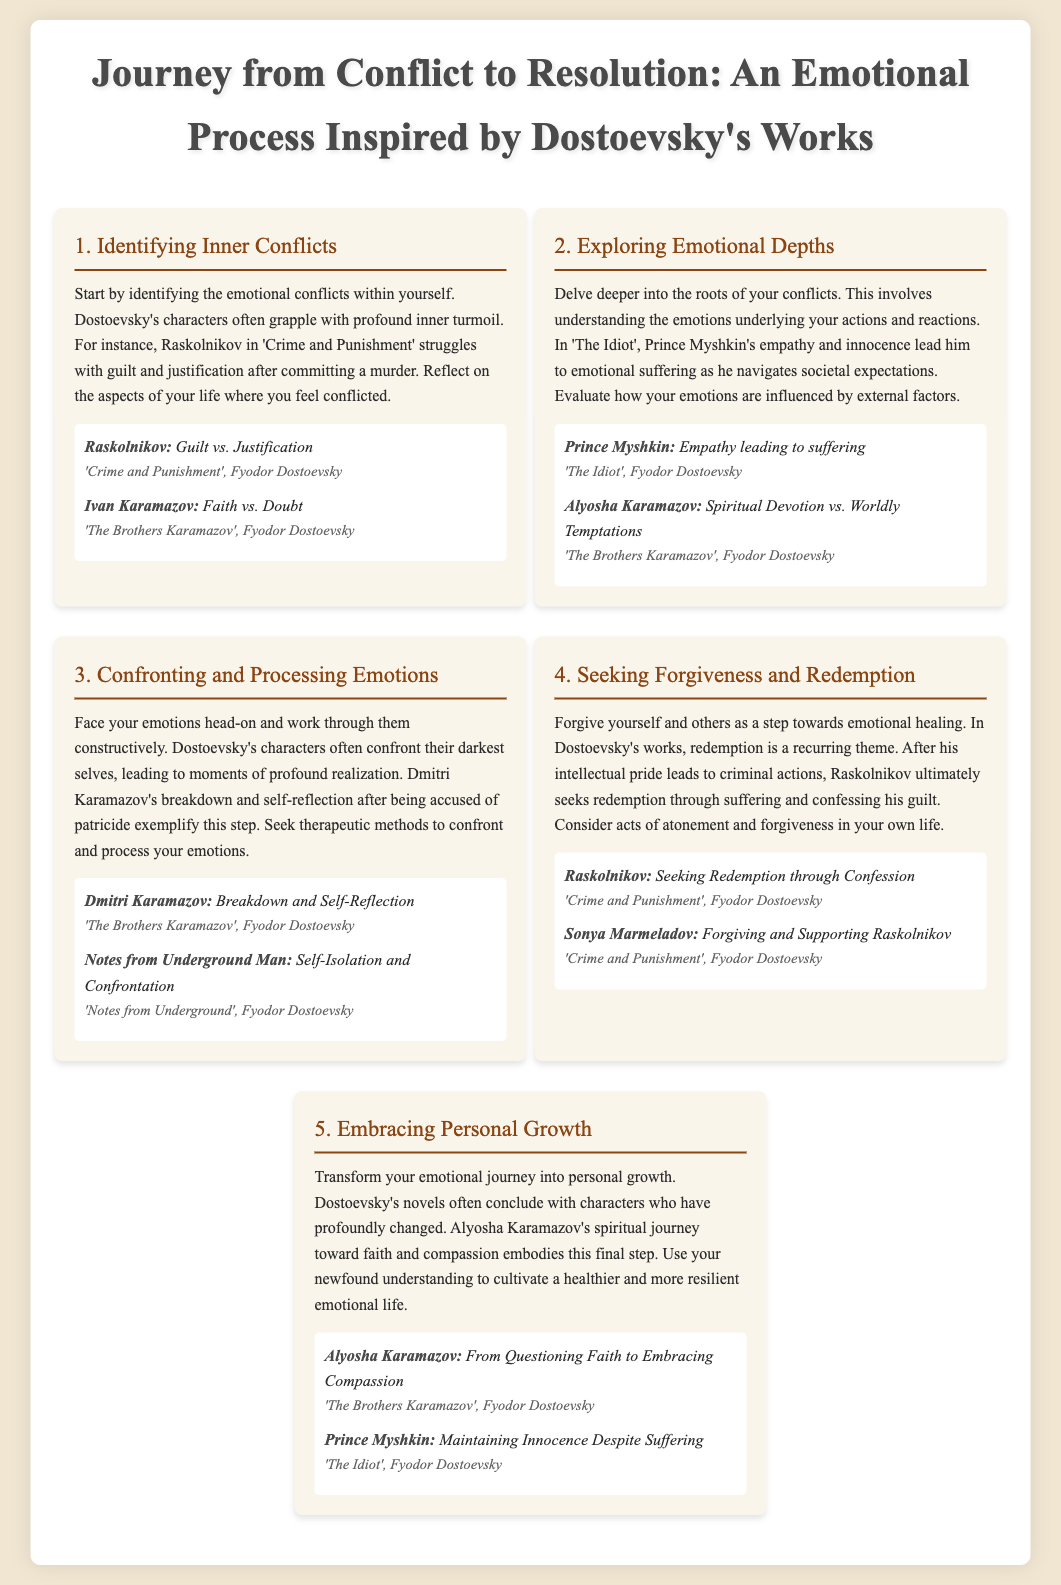what is the title of the document? The title is presented prominently at the top of the infographic, summarizing the theme of the process illustrated.
Answer: Journey from Conflict to Resolution: An Emotional Process Inspired by Dostoevsky's Works who struggles with guilt and justification in 'Crime and Punishment'? The document mentions the character associated with guilt and justification, illustrating a central conflict in Dostoevsky's work.
Answer: Raskolnikov which character faces the emotional conflict of empathy leading to suffering? This character embodies the theme of the emotional depth explored in the document and is a key figure in one of Dostoevsky's novels.
Answer: Prince Myshkin how many steps are outlined in the emotional process? The document presents a clearly delineated process encompassing various stages that one might go through.
Answer: Five which character seeks redemption through confession? The document highlights this character's ultimate journey towards redemption and illustrates a significant emotional resolution.
Answer: Raskolnikov what emotion does Dmitri Karamazov confront in 'The Brothers Karamazov'? This character's experience is cited as a key moment of realization in the document, illustrating the face of one's inner turmoil.
Answer: Self-Reflection what is the theme of the final step in the emotional process? The concluding step emphasizes the transformation and growth resulting from the emotional journey depicted throughout the document.
Answer: Personal Growth which character maintains innocence despite suffering? This character's journey is an example of the profound changes that can occur through emotional exploration, showcasing resilience.
Answer: Prince Myshkin 